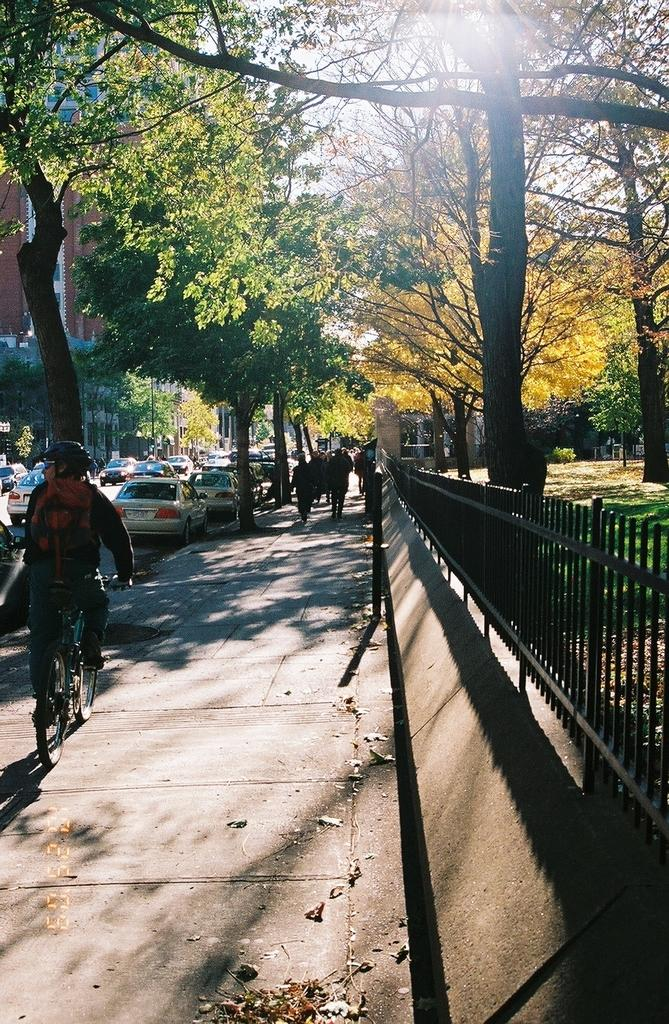How many people are in the image? There are people in the image, but the exact number is not specified. What is one person doing in the image? One person is cycling a cycle in the image. What can be seen in the background of the image? There are vehicles, trees, and a building in the background of the image. What type of sound can be heard coming from the beam in the image? There is no beam present in the image, so it is not possible to determine what sound might be coming from it. 